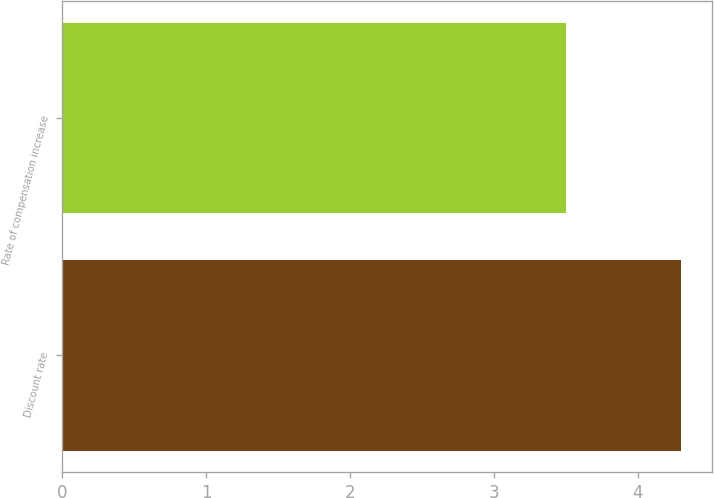Convert chart to OTSL. <chart><loc_0><loc_0><loc_500><loc_500><bar_chart><fcel>Discount rate<fcel>Rate of compensation increase<nl><fcel>4.3<fcel>3.5<nl></chart> 